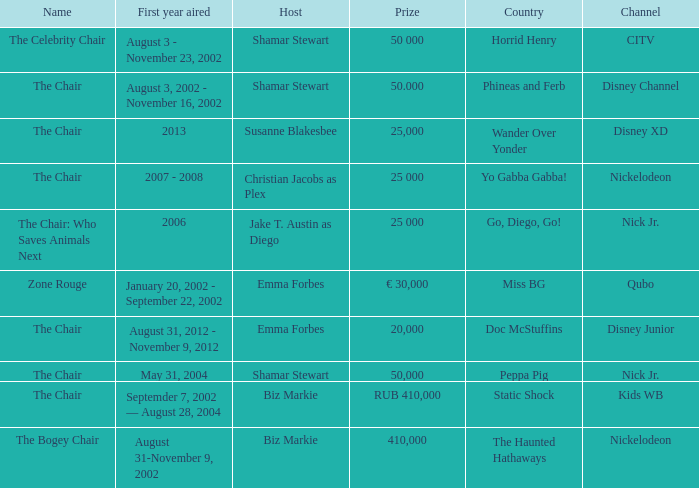Give me the full table as a dictionary. {'header': ['Name', 'First year aired', 'Host', 'Prize', 'Country', 'Channel'], 'rows': [['The Celebrity Chair', 'August 3 - November 23, 2002', 'Shamar Stewart', '50 000', 'Horrid Henry', 'CITV'], ['The Chair', 'August 3, 2002 - November 16, 2002', 'Shamar Stewart', '50.000', 'Phineas and Ferb', 'Disney Channel'], ['The Chair', '2013', 'Susanne Blakesbee', '25,000', 'Wander Over Yonder', 'Disney XD'], ['The Chair', '2007 - 2008', 'Christian Jacobs as Plex', '25 000', 'Yo Gabba Gabba!', 'Nickelodeon'], ['The Chair: Who Saves Animals Next', '2006', 'Jake T. Austin as Diego', '25 000', 'Go, Diego, Go!', 'Nick Jr.'], ['Zone Rouge', 'January 20, 2002 - September 22, 2002', 'Emma Forbes', '€ 30,000', 'Miss BG', 'Qubo'], ['The Chair', 'August 31, 2012 - November 9, 2012', 'Emma Forbes', '20,000', 'Doc McStuffins', 'Disney Junior'], ['The Chair', 'May 31, 2004', 'Shamar Stewart', '50,000', 'Peppa Pig', 'Nick Jr.'], ['The Chair', 'Septemder 7, 2002 — August 28, 2004', 'Biz Markie', 'RUB 410,000', 'Static Shock', 'Kids WB'], ['The Bogey Chair', 'August 31-November 9, 2002', 'Biz Markie', '410,000', 'The Haunted Hathaways', 'Nickelodeon']]} What year did Zone Rouge first air? January 20, 2002 - September 22, 2002. 